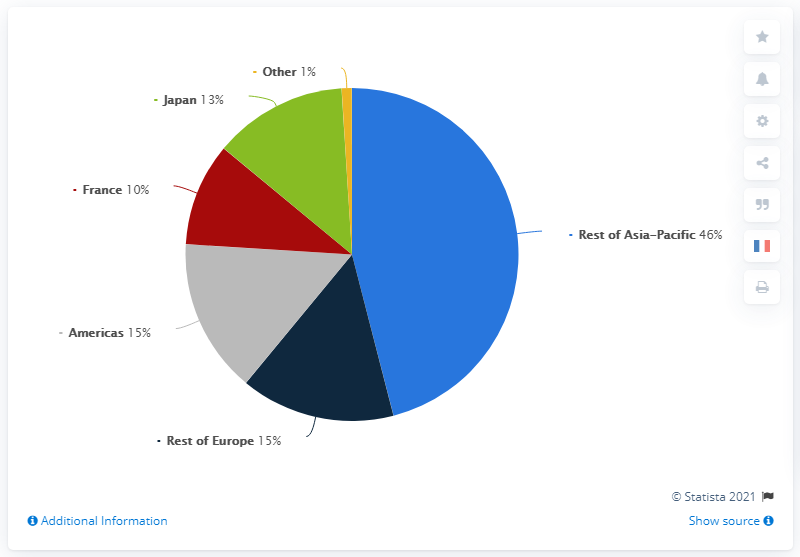Point out several critical features in this image. In total, the share of Asian countries is 59%. Japan's share is 13%. 